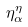<formula> <loc_0><loc_0><loc_500><loc_500>\eta _ { \alpha } ^ { \eta }</formula> 